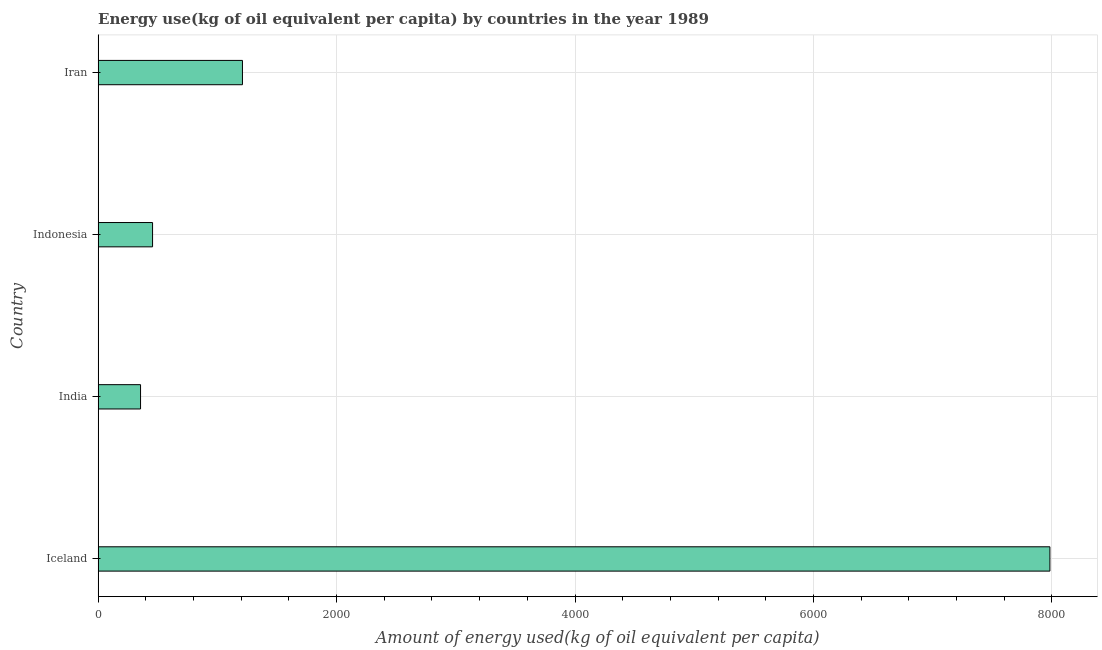Does the graph contain any zero values?
Give a very brief answer. No. Does the graph contain grids?
Offer a terse response. Yes. What is the title of the graph?
Offer a very short reply. Energy use(kg of oil equivalent per capita) by countries in the year 1989. What is the label or title of the X-axis?
Provide a short and direct response. Amount of energy used(kg of oil equivalent per capita). What is the label or title of the Y-axis?
Offer a very short reply. Country. What is the amount of energy used in Iran?
Give a very brief answer. 1210.55. Across all countries, what is the maximum amount of energy used?
Your response must be concise. 7983.04. Across all countries, what is the minimum amount of energy used?
Provide a succinct answer. 355.86. In which country was the amount of energy used maximum?
Provide a short and direct response. Iceland. What is the sum of the amount of energy used?
Provide a short and direct response. 1.00e+04. What is the difference between the amount of energy used in Indonesia and Iran?
Your answer should be compact. -753.84. What is the average amount of energy used per country?
Offer a very short reply. 2501.54. What is the median amount of energy used?
Your answer should be very brief. 833.63. In how many countries, is the amount of energy used greater than 6000 kg?
Give a very brief answer. 1. What is the ratio of the amount of energy used in Iceland to that in India?
Provide a short and direct response. 22.43. Is the difference between the amount of energy used in Iceland and Indonesia greater than the difference between any two countries?
Provide a succinct answer. No. What is the difference between the highest and the second highest amount of energy used?
Give a very brief answer. 6772.49. Is the sum of the amount of energy used in Indonesia and Iran greater than the maximum amount of energy used across all countries?
Provide a short and direct response. No. What is the difference between the highest and the lowest amount of energy used?
Give a very brief answer. 7627.18. How many bars are there?
Give a very brief answer. 4. Are the values on the major ticks of X-axis written in scientific E-notation?
Ensure brevity in your answer.  No. What is the Amount of energy used(kg of oil equivalent per capita) of Iceland?
Your answer should be very brief. 7983.04. What is the Amount of energy used(kg of oil equivalent per capita) of India?
Your answer should be very brief. 355.86. What is the Amount of energy used(kg of oil equivalent per capita) of Indonesia?
Provide a succinct answer. 456.71. What is the Amount of energy used(kg of oil equivalent per capita) of Iran?
Your answer should be compact. 1210.55. What is the difference between the Amount of energy used(kg of oil equivalent per capita) in Iceland and India?
Your response must be concise. 7627.18. What is the difference between the Amount of energy used(kg of oil equivalent per capita) in Iceland and Indonesia?
Ensure brevity in your answer.  7526.33. What is the difference between the Amount of energy used(kg of oil equivalent per capita) in Iceland and Iran?
Keep it short and to the point. 6772.49. What is the difference between the Amount of energy used(kg of oil equivalent per capita) in India and Indonesia?
Make the answer very short. -100.85. What is the difference between the Amount of energy used(kg of oil equivalent per capita) in India and Iran?
Provide a succinct answer. -854.69. What is the difference between the Amount of energy used(kg of oil equivalent per capita) in Indonesia and Iran?
Offer a terse response. -753.84. What is the ratio of the Amount of energy used(kg of oil equivalent per capita) in Iceland to that in India?
Give a very brief answer. 22.43. What is the ratio of the Amount of energy used(kg of oil equivalent per capita) in Iceland to that in Indonesia?
Offer a terse response. 17.48. What is the ratio of the Amount of energy used(kg of oil equivalent per capita) in Iceland to that in Iran?
Offer a terse response. 6.59. What is the ratio of the Amount of energy used(kg of oil equivalent per capita) in India to that in Indonesia?
Make the answer very short. 0.78. What is the ratio of the Amount of energy used(kg of oil equivalent per capita) in India to that in Iran?
Ensure brevity in your answer.  0.29. What is the ratio of the Amount of energy used(kg of oil equivalent per capita) in Indonesia to that in Iran?
Your response must be concise. 0.38. 